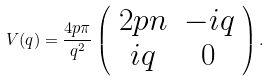<formula> <loc_0><loc_0><loc_500><loc_500>V ( { q } ) = \frac { 4 p \pi } { q ^ { 2 } } \left ( \begin{array} { c c } 2 p n & - i q \\ i q & 0 \end{array} \right ) .</formula> 